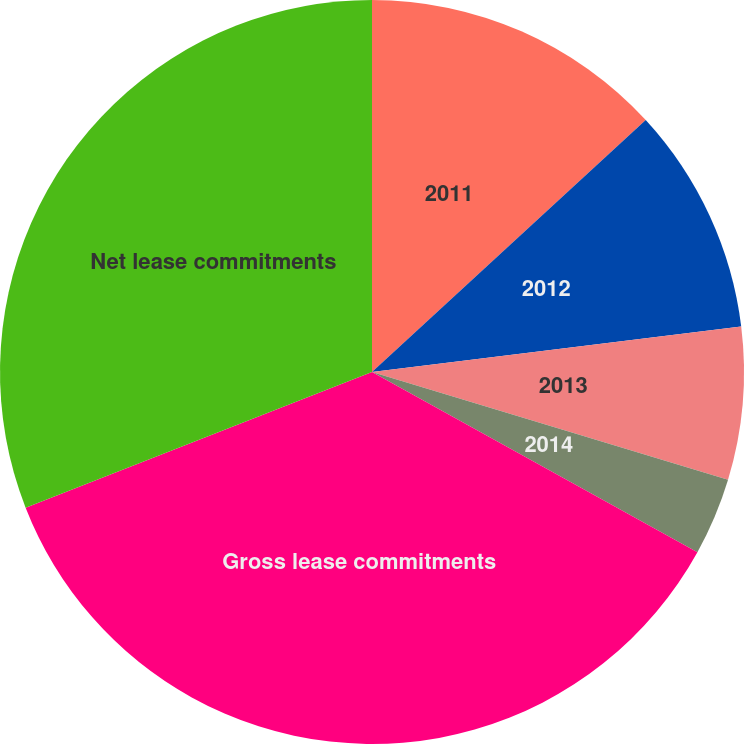Convert chart to OTSL. <chart><loc_0><loc_0><loc_500><loc_500><pie_chart><fcel>2011<fcel>2012<fcel>2013<fcel>2014<fcel>Gross lease commitments<fcel>Net lease commitments<nl><fcel>13.16%<fcel>9.89%<fcel>6.63%<fcel>3.37%<fcel>36.01%<fcel>30.94%<nl></chart> 